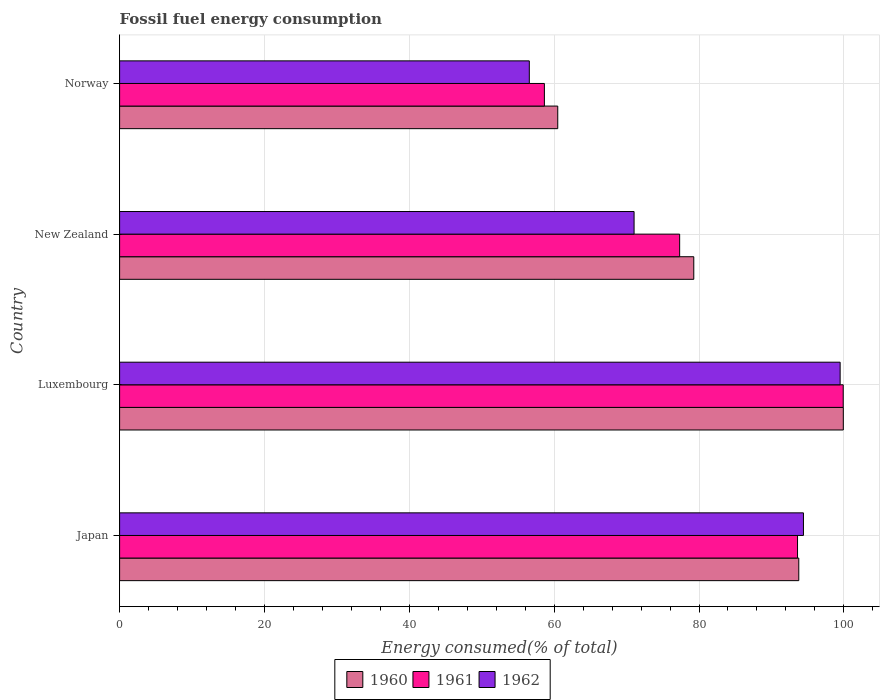How many groups of bars are there?
Give a very brief answer. 4. Are the number of bars on each tick of the Y-axis equal?
Offer a terse response. Yes. How many bars are there on the 2nd tick from the top?
Provide a short and direct response. 3. How many bars are there on the 3rd tick from the bottom?
Make the answer very short. 3. What is the percentage of energy consumed in 1962 in New Zealand?
Provide a succinct answer. 71.04. Across all countries, what is the maximum percentage of energy consumed in 1962?
Make the answer very short. 99.49. Across all countries, what is the minimum percentage of energy consumed in 1962?
Give a very brief answer. 56.57. In which country was the percentage of energy consumed in 1961 maximum?
Ensure brevity in your answer.  Luxembourg. What is the total percentage of energy consumed in 1962 in the graph?
Offer a terse response. 321.51. What is the difference between the percentage of energy consumed in 1961 in Japan and that in New Zealand?
Your answer should be compact. 16.28. What is the difference between the percentage of energy consumed in 1962 in Japan and the percentage of energy consumed in 1960 in Norway?
Ensure brevity in your answer.  33.92. What is the average percentage of energy consumed in 1960 per country?
Provide a succinct answer. 83.37. What is the difference between the percentage of energy consumed in 1961 and percentage of energy consumed in 1960 in Japan?
Your answer should be compact. -0.17. What is the ratio of the percentage of energy consumed in 1960 in New Zealand to that in Norway?
Keep it short and to the point. 1.31. Is the difference between the percentage of energy consumed in 1961 in Japan and Luxembourg greater than the difference between the percentage of energy consumed in 1960 in Japan and Luxembourg?
Your answer should be very brief. No. What is the difference between the highest and the second highest percentage of energy consumed in 1960?
Provide a short and direct response. 6.15. What is the difference between the highest and the lowest percentage of energy consumed in 1962?
Your answer should be very brief. 42.92. In how many countries, is the percentage of energy consumed in 1962 greater than the average percentage of energy consumed in 1962 taken over all countries?
Ensure brevity in your answer.  2. What does the 3rd bar from the top in Luxembourg represents?
Offer a very short reply. 1960. What does the 3rd bar from the bottom in New Zealand represents?
Offer a very short reply. 1962. Are all the bars in the graph horizontal?
Keep it short and to the point. Yes. Does the graph contain any zero values?
Provide a succinct answer. No. Where does the legend appear in the graph?
Give a very brief answer. Bottom center. How many legend labels are there?
Offer a very short reply. 3. What is the title of the graph?
Make the answer very short. Fossil fuel energy consumption. Does "1980" appear as one of the legend labels in the graph?
Provide a succinct answer. No. What is the label or title of the X-axis?
Offer a very short reply. Energy consumed(% of total). What is the label or title of the Y-axis?
Ensure brevity in your answer.  Country. What is the Energy consumed(% of total) in 1960 in Japan?
Offer a very short reply. 93.78. What is the Energy consumed(% of total) of 1961 in Japan?
Make the answer very short. 93.6. What is the Energy consumed(% of total) of 1962 in Japan?
Your answer should be compact. 94.42. What is the Energy consumed(% of total) in 1960 in Luxembourg?
Keep it short and to the point. 99.92. What is the Energy consumed(% of total) in 1961 in Luxembourg?
Give a very brief answer. 99.91. What is the Energy consumed(% of total) in 1962 in Luxembourg?
Offer a terse response. 99.49. What is the Energy consumed(% of total) in 1960 in New Zealand?
Ensure brevity in your answer.  79.28. What is the Energy consumed(% of total) of 1961 in New Zealand?
Ensure brevity in your answer.  77.33. What is the Energy consumed(% of total) in 1962 in New Zealand?
Give a very brief answer. 71.04. What is the Energy consumed(% of total) in 1960 in Norway?
Your response must be concise. 60.5. What is the Energy consumed(% of total) in 1961 in Norway?
Provide a succinct answer. 58.65. What is the Energy consumed(% of total) in 1962 in Norway?
Offer a terse response. 56.57. Across all countries, what is the maximum Energy consumed(% of total) in 1960?
Offer a very short reply. 99.92. Across all countries, what is the maximum Energy consumed(% of total) of 1961?
Your answer should be compact. 99.91. Across all countries, what is the maximum Energy consumed(% of total) of 1962?
Provide a succinct answer. 99.49. Across all countries, what is the minimum Energy consumed(% of total) of 1960?
Provide a succinct answer. 60.5. Across all countries, what is the minimum Energy consumed(% of total) of 1961?
Ensure brevity in your answer.  58.65. Across all countries, what is the minimum Energy consumed(% of total) of 1962?
Ensure brevity in your answer.  56.57. What is the total Energy consumed(% of total) of 1960 in the graph?
Your answer should be very brief. 333.48. What is the total Energy consumed(% of total) in 1961 in the graph?
Ensure brevity in your answer.  329.5. What is the total Energy consumed(% of total) of 1962 in the graph?
Keep it short and to the point. 321.51. What is the difference between the Energy consumed(% of total) of 1960 in Japan and that in Luxembourg?
Your response must be concise. -6.15. What is the difference between the Energy consumed(% of total) in 1961 in Japan and that in Luxembourg?
Ensure brevity in your answer.  -6.31. What is the difference between the Energy consumed(% of total) in 1962 in Japan and that in Luxembourg?
Provide a short and direct response. -5.07. What is the difference between the Energy consumed(% of total) of 1960 in Japan and that in New Zealand?
Offer a terse response. 14.5. What is the difference between the Energy consumed(% of total) in 1961 in Japan and that in New Zealand?
Offer a terse response. 16.28. What is the difference between the Energy consumed(% of total) in 1962 in Japan and that in New Zealand?
Keep it short and to the point. 23.38. What is the difference between the Energy consumed(% of total) of 1960 in Japan and that in Norway?
Your answer should be compact. 33.28. What is the difference between the Energy consumed(% of total) of 1961 in Japan and that in Norway?
Provide a short and direct response. 34.95. What is the difference between the Energy consumed(% of total) of 1962 in Japan and that in Norway?
Provide a succinct answer. 37.85. What is the difference between the Energy consumed(% of total) in 1960 in Luxembourg and that in New Zealand?
Ensure brevity in your answer.  20.65. What is the difference between the Energy consumed(% of total) in 1961 in Luxembourg and that in New Zealand?
Offer a very short reply. 22.58. What is the difference between the Energy consumed(% of total) of 1962 in Luxembourg and that in New Zealand?
Keep it short and to the point. 28.45. What is the difference between the Energy consumed(% of total) in 1960 in Luxembourg and that in Norway?
Make the answer very short. 39.43. What is the difference between the Energy consumed(% of total) of 1961 in Luxembourg and that in Norway?
Provide a succinct answer. 41.26. What is the difference between the Energy consumed(% of total) of 1962 in Luxembourg and that in Norway?
Your answer should be compact. 42.92. What is the difference between the Energy consumed(% of total) in 1960 in New Zealand and that in Norway?
Offer a very short reply. 18.78. What is the difference between the Energy consumed(% of total) of 1961 in New Zealand and that in Norway?
Give a very brief answer. 18.68. What is the difference between the Energy consumed(% of total) of 1962 in New Zealand and that in Norway?
Your answer should be very brief. 14.47. What is the difference between the Energy consumed(% of total) of 1960 in Japan and the Energy consumed(% of total) of 1961 in Luxembourg?
Offer a very short reply. -6.14. What is the difference between the Energy consumed(% of total) of 1960 in Japan and the Energy consumed(% of total) of 1962 in Luxembourg?
Offer a terse response. -5.71. What is the difference between the Energy consumed(% of total) of 1961 in Japan and the Energy consumed(% of total) of 1962 in Luxembourg?
Your response must be concise. -5.88. What is the difference between the Energy consumed(% of total) of 1960 in Japan and the Energy consumed(% of total) of 1961 in New Zealand?
Your answer should be compact. 16.45. What is the difference between the Energy consumed(% of total) of 1960 in Japan and the Energy consumed(% of total) of 1962 in New Zealand?
Ensure brevity in your answer.  22.74. What is the difference between the Energy consumed(% of total) in 1961 in Japan and the Energy consumed(% of total) in 1962 in New Zealand?
Provide a short and direct response. 22.57. What is the difference between the Energy consumed(% of total) in 1960 in Japan and the Energy consumed(% of total) in 1961 in Norway?
Offer a very short reply. 35.12. What is the difference between the Energy consumed(% of total) in 1960 in Japan and the Energy consumed(% of total) in 1962 in Norway?
Your answer should be very brief. 37.21. What is the difference between the Energy consumed(% of total) of 1961 in Japan and the Energy consumed(% of total) of 1962 in Norway?
Provide a short and direct response. 37.03. What is the difference between the Energy consumed(% of total) in 1960 in Luxembourg and the Energy consumed(% of total) in 1961 in New Zealand?
Offer a terse response. 22.6. What is the difference between the Energy consumed(% of total) in 1960 in Luxembourg and the Energy consumed(% of total) in 1962 in New Zealand?
Your answer should be very brief. 28.89. What is the difference between the Energy consumed(% of total) in 1961 in Luxembourg and the Energy consumed(% of total) in 1962 in New Zealand?
Your answer should be very brief. 28.88. What is the difference between the Energy consumed(% of total) of 1960 in Luxembourg and the Energy consumed(% of total) of 1961 in Norway?
Provide a succinct answer. 41.27. What is the difference between the Energy consumed(% of total) in 1960 in Luxembourg and the Energy consumed(% of total) in 1962 in Norway?
Your answer should be very brief. 43.35. What is the difference between the Energy consumed(% of total) in 1961 in Luxembourg and the Energy consumed(% of total) in 1962 in Norway?
Keep it short and to the point. 43.34. What is the difference between the Energy consumed(% of total) of 1960 in New Zealand and the Energy consumed(% of total) of 1961 in Norway?
Your response must be concise. 20.63. What is the difference between the Energy consumed(% of total) of 1960 in New Zealand and the Energy consumed(% of total) of 1962 in Norway?
Ensure brevity in your answer.  22.71. What is the difference between the Energy consumed(% of total) of 1961 in New Zealand and the Energy consumed(% of total) of 1962 in Norway?
Make the answer very short. 20.76. What is the average Energy consumed(% of total) in 1960 per country?
Keep it short and to the point. 83.37. What is the average Energy consumed(% of total) of 1961 per country?
Provide a short and direct response. 82.37. What is the average Energy consumed(% of total) of 1962 per country?
Keep it short and to the point. 80.38. What is the difference between the Energy consumed(% of total) in 1960 and Energy consumed(% of total) in 1961 in Japan?
Keep it short and to the point. 0.17. What is the difference between the Energy consumed(% of total) in 1960 and Energy consumed(% of total) in 1962 in Japan?
Provide a short and direct response. -0.64. What is the difference between the Energy consumed(% of total) in 1961 and Energy consumed(% of total) in 1962 in Japan?
Ensure brevity in your answer.  -0.82. What is the difference between the Energy consumed(% of total) in 1960 and Energy consumed(% of total) in 1961 in Luxembourg?
Provide a short and direct response. 0.01. What is the difference between the Energy consumed(% of total) of 1960 and Energy consumed(% of total) of 1962 in Luxembourg?
Your answer should be very brief. 0.44. What is the difference between the Energy consumed(% of total) of 1961 and Energy consumed(% of total) of 1962 in Luxembourg?
Give a very brief answer. 0.42. What is the difference between the Energy consumed(% of total) of 1960 and Energy consumed(% of total) of 1961 in New Zealand?
Your answer should be very brief. 1.95. What is the difference between the Energy consumed(% of total) of 1960 and Energy consumed(% of total) of 1962 in New Zealand?
Your response must be concise. 8.24. What is the difference between the Energy consumed(% of total) of 1961 and Energy consumed(% of total) of 1962 in New Zealand?
Your answer should be very brief. 6.29. What is the difference between the Energy consumed(% of total) of 1960 and Energy consumed(% of total) of 1961 in Norway?
Give a very brief answer. 1.85. What is the difference between the Energy consumed(% of total) of 1960 and Energy consumed(% of total) of 1962 in Norway?
Make the answer very short. 3.93. What is the difference between the Energy consumed(% of total) of 1961 and Energy consumed(% of total) of 1962 in Norway?
Provide a short and direct response. 2.08. What is the ratio of the Energy consumed(% of total) of 1960 in Japan to that in Luxembourg?
Your answer should be very brief. 0.94. What is the ratio of the Energy consumed(% of total) in 1961 in Japan to that in Luxembourg?
Your answer should be compact. 0.94. What is the ratio of the Energy consumed(% of total) of 1962 in Japan to that in Luxembourg?
Keep it short and to the point. 0.95. What is the ratio of the Energy consumed(% of total) in 1960 in Japan to that in New Zealand?
Ensure brevity in your answer.  1.18. What is the ratio of the Energy consumed(% of total) of 1961 in Japan to that in New Zealand?
Offer a terse response. 1.21. What is the ratio of the Energy consumed(% of total) of 1962 in Japan to that in New Zealand?
Your answer should be compact. 1.33. What is the ratio of the Energy consumed(% of total) in 1960 in Japan to that in Norway?
Your answer should be very brief. 1.55. What is the ratio of the Energy consumed(% of total) in 1961 in Japan to that in Norway?
Give a very brief answer. 1.6. What is the ratio of the Energy consumed(% of total) in 1962 in Japan to that in Norway?
Ensure brevity in your answer.  1.67. What is the ratio of the Energy consumed(% of total) in 1960 in Luxembourg to that in New Zealand?
Make the answer very short. 1.26. What is the ratio of the Energy consumed(% of total) of 1961 in Luxembourg to that in New Zealand?
Ensure brevity in your answer.  1.29. What is the ratio of the Energy consumed(% of total) in 1962 in Luxembourg to that in New Zealand?
Offer a very short reply. 1.4. What is the ratio of the Energy consumed(% of total) of 1960 in Luxembourg to that in Norway?
Keep it short and to the point. 1.65. What is the ratio of the Energy consumed(% of total) in 1961 in Luxembourg to that in Norway?
Your response must be concise. 1.7. What is the ratio of the Energy consumed(% of total) of 1962 in Luxembourg to that in Norway?
Provide a succinct answer. 1.76. What is the ratio of the Energy consumed(% of total) of 1960 in New Zealand to that in Norway?
Offer a terse response. 1.31. What is the ratio of the Energy consumed(% of total) of 1961 in New Zealand to that in Norway?
Offer a terse response. 1.32. What is the ratio of the Energy consumed(% of total) in 1962 in New Zealand to that in Norway?
Offer a very short reply. 1.26. What is the difference between the highest and the second highest Energy consumed(% of total) in 1960?
Your answer should be compact. 6.15. What is the difference between the highest and the second highest Energy consumed(% of total) of 1961?
Keep it short and to the point. 6.31. What is the difference between the highest and the second highest Energy consumed(% of total) of 1962?
Your answer should be compact. 5.07. What is the difference between the highest and the lowest Energy consumed(% of total) of 1960?
Offer a very short reply. 39.43. What is the difference between the highest and the lowest Energy consumed(% of total) in 1961?
Make the answer very short. 41.26. What is the difference between the highest and the lowest Energy consumed(% of total) of 1962?
Your answer should be compact. 42.92. 